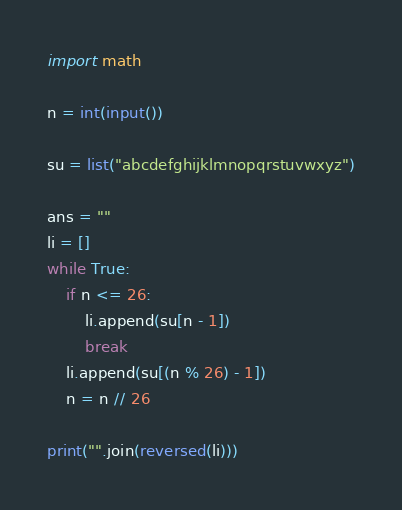Convert code to text. <code><loc_0><loc_0><loc_500><loc_500><_Python_>import math

n = int(input())

su = list("abcdefghijklmnopqrstuvwxyz")

ans = ""
li = []
while True:
    if n <= 26:
        li.append(su[n - 1])
        break
    li.append(su[(n % 26) - 1])
    n = n // 26

print("".join(reversed(li)))</code> 